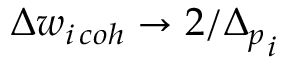Convert formula to latex. <formula><loc_0><loc_0><loc_500><loc_500>\Delta w _ { i \, c o h } \to 2 / { \Delta _ { p } } _ { i }</formula> 